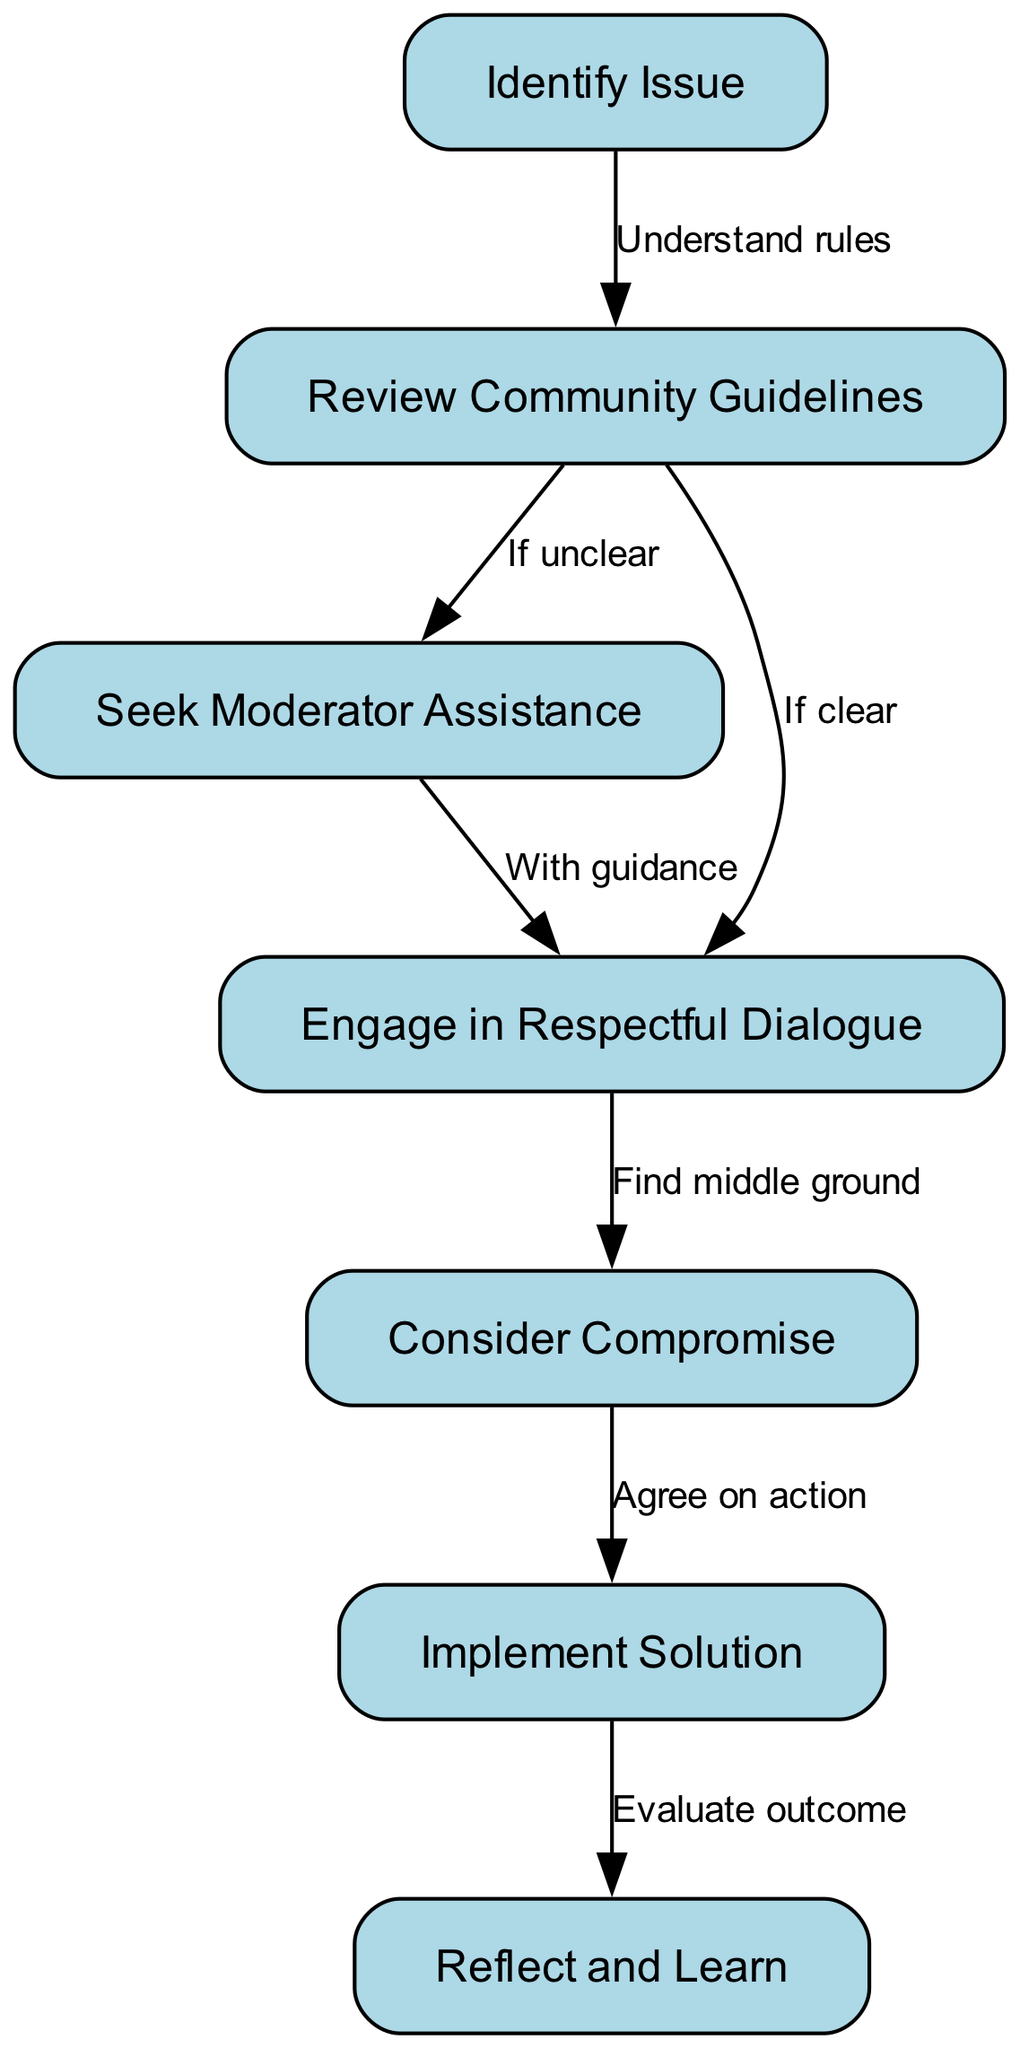What is the first step in the conflict resolution process? The diagram outlines a series of steps in the conflict resolution process, starting with "Identify Issue" as the very first node in the flow.
Answer: Identify Issue How many total nodes are there in the diagram? Counting all the nodes listed in the diagram, we find there are seven distinct steps involved in the conflict resolution process.
Answer: 7 What does the edge between node 2 and node 3 signify? The edge between node 2, "Review Community Guidelines," and node 3, "Seek Moderator Assistance", indicates that if the community guidelines are unclear, the next step is to seek help from a moderator.
Answer: If unclear What step follows after engaging in respectful dialogue? After "Engage in Respectful Dialogue", the next step according to the diagram is to "Consider Compromise", indicating a progression towards resolution.
Answer: Consider Compromise What action is taken after implementing the solution? The final step after "Implement Solution" is "Reflect and Learn," which emphasizes the importance of evaluating the outcome of the conflict resolution process.
Answer: Reflect and Learn What action is suggested if the community guidelines are clear? If the community guidelines are clear, the process directs users to "Engage in Respectful Dialogue" as the following action step.
Answer: Engage in Respectful Dialogue How are the nodes connected from issue identification to resolution? The nodes are sequentially connected where each node leads to the next, starting from "Identify Issue" through to "Reflect and Learn", creating a clear path of actions to resolve conflicts.
Answer: Sequentially connected What does "Agree on action" relate to in the process? "Agree on action" is directly related to the node "Consider Compromise," indicating that once a compromise is found, the parties involved should agree on the specific action to be taken next.
Answer: Agree on action 